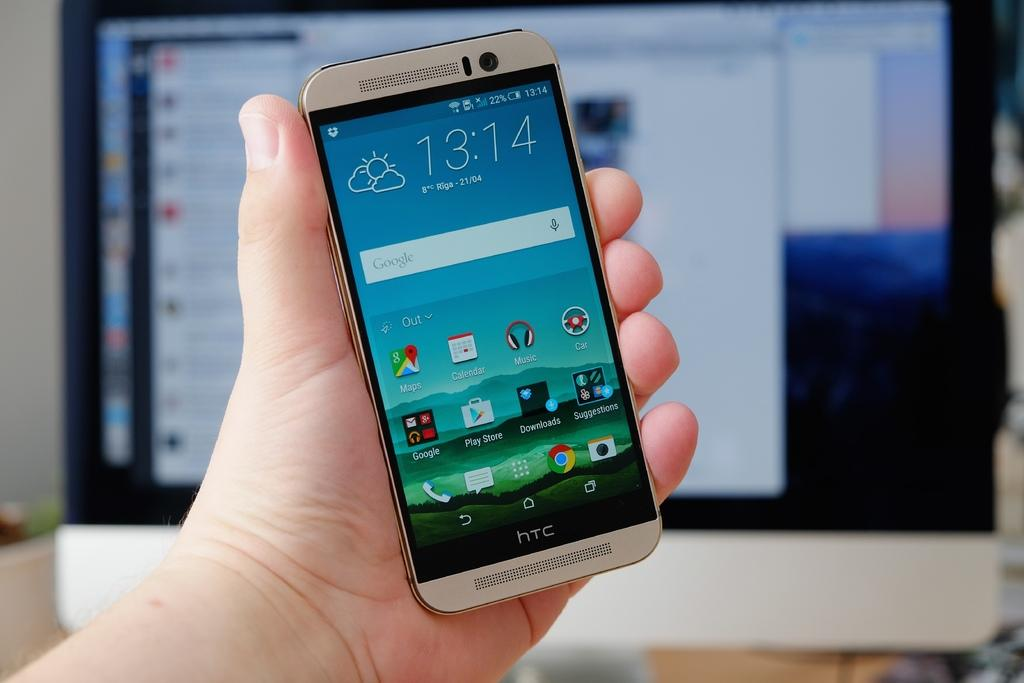<image>
Share a concise interpretation of the image provided. On April 21 it is 8 degrees Celsius in Riga. 